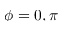<formula> <loc_0><loc_0><loc_500><loc_500>\phi = 0 , \pi</formula> 